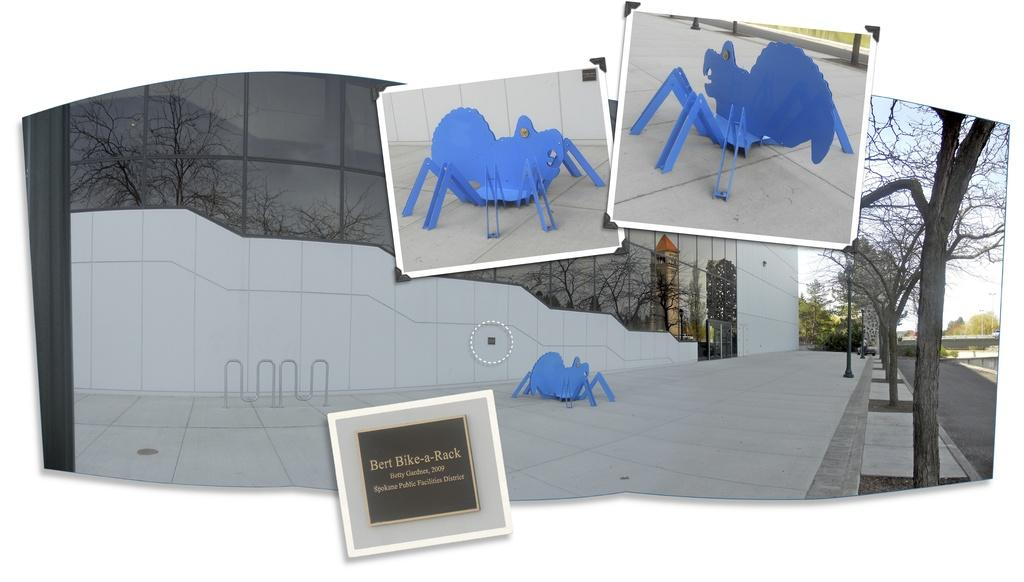<image>
Describe the image concisely. A bike rack sculpture, punnily named Bert Bike-a-Rack. 